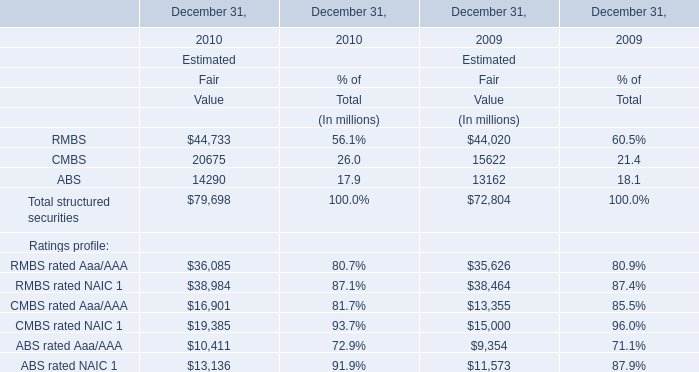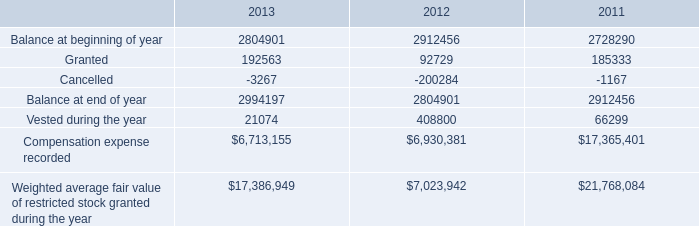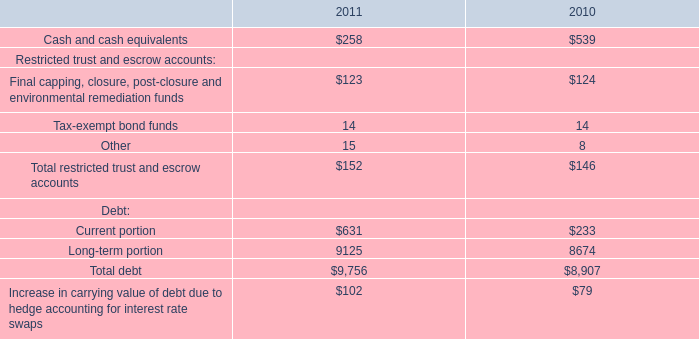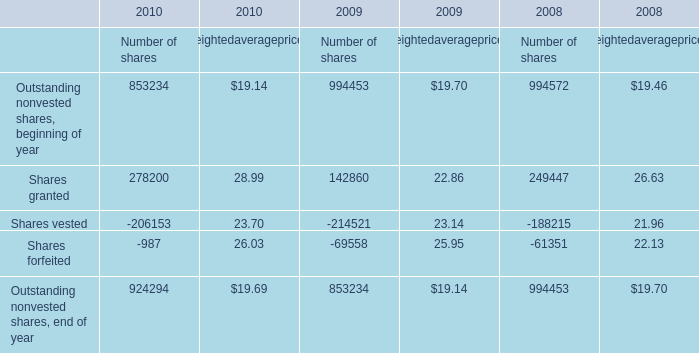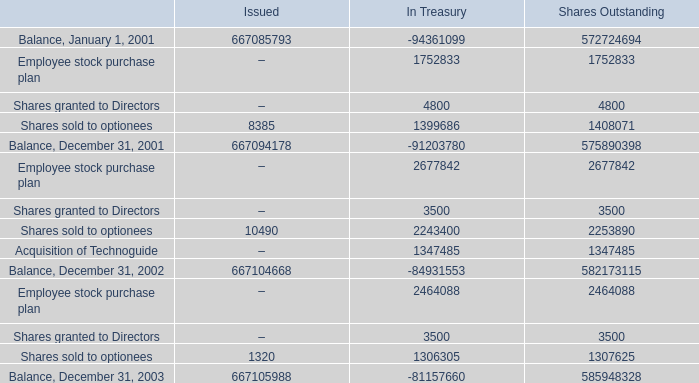what was amount of shares issued to directors during the period? 
Computations: ((4800 + 3500) + 3500)
Answer: 11800.0. 